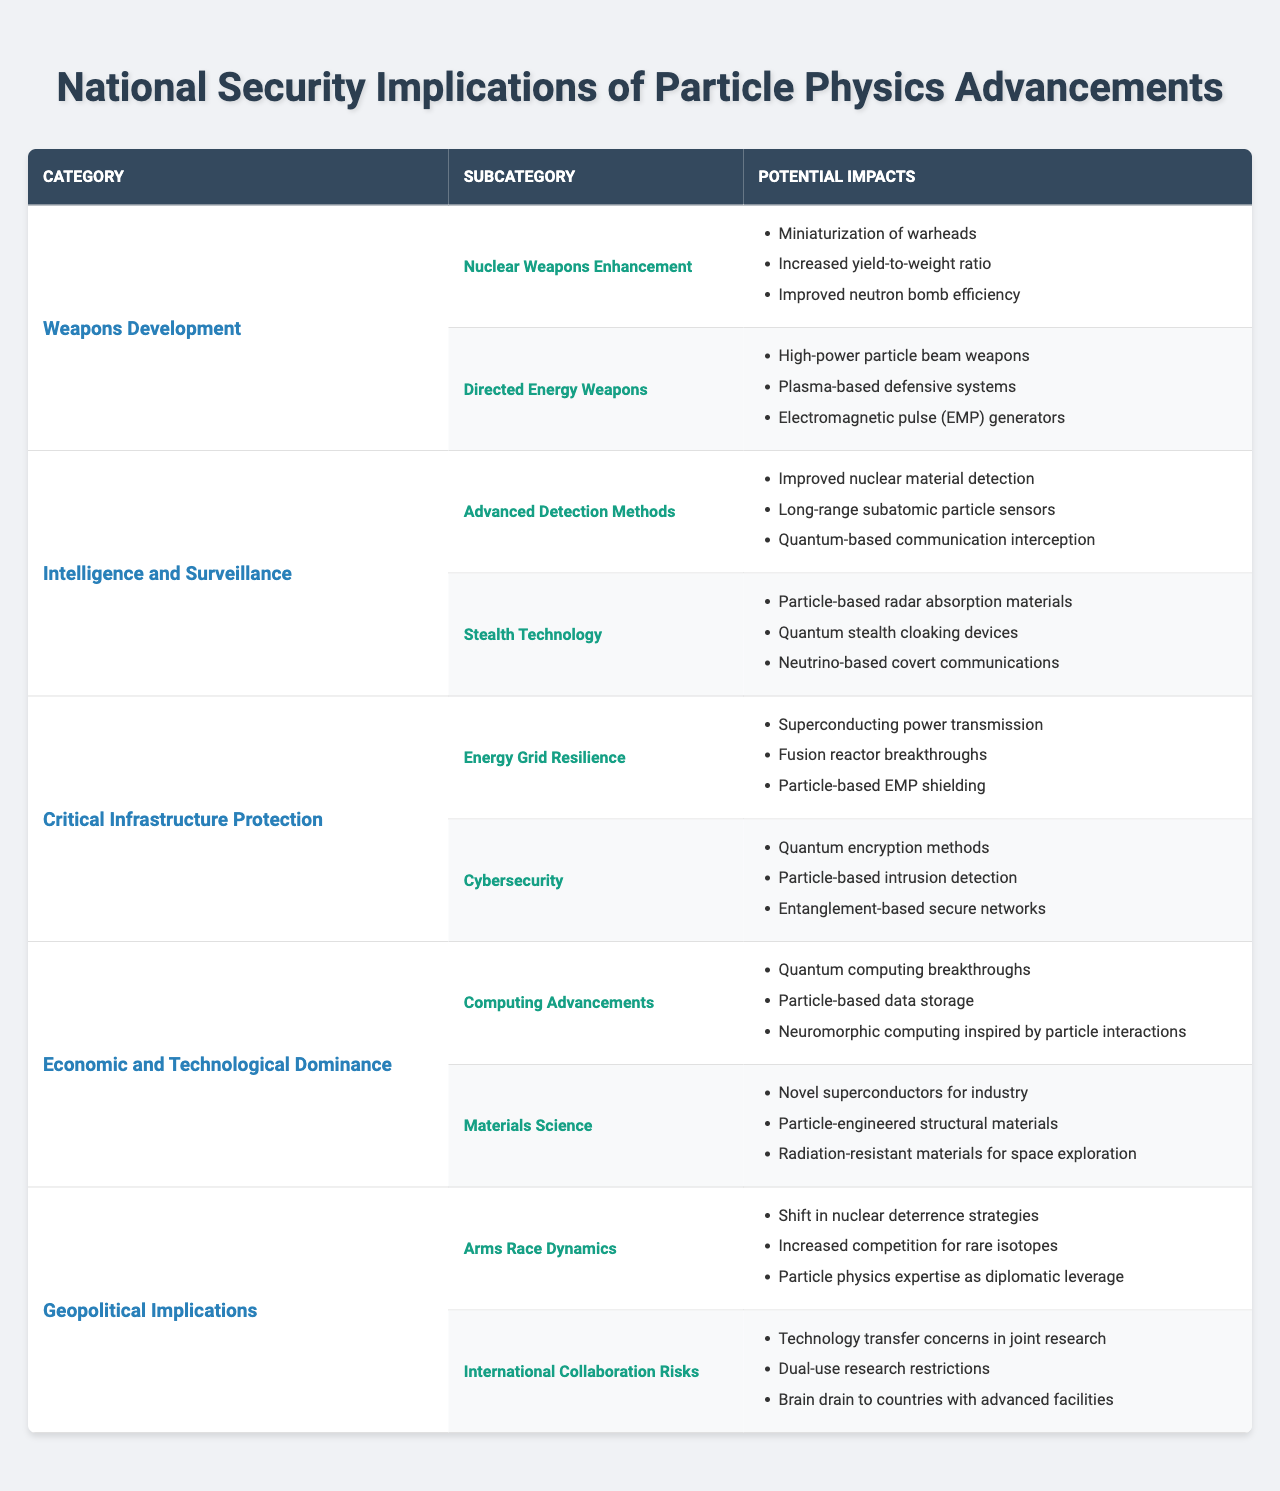What are the potential impacts listed under "Nuclear Weapons Enhancement"? According to the table, the potential impacts listed under "Nuclear Weapons Enhancement" are miniaturization of warheads, increased yield-to-weight ratio, and improved neutron bomb efficiency.
Answer: Miniaturization of warheads, increased yield-to-weight ratio, improved neutron bomb efficiency How many subcategories are under the "Intelligence and Surveillance" category? The table shows that there are two subcategories listed under "Intelligence and Surveillance": Advanced Detection Methods and Stealth Technology. Therefore, the number of subcategories is 2.
Answer: 2 Which potential impact is associated with "Quantum Computing Advancements"? The table indicates that the potential impacts associated with "Quantum Computing Advancements" are quantum computing breakthroughs, particle-based data storage, and neuromorphic computing inspired by particle interactions.
Answer: Quantum computing breakthroughs, particle-based data storage, neuromorphic computing inspired by particle interactions Are directed energy weapons listed as a subcategory under any category? Yes, based on the table, directed energy weapons is listed as a subcategory under "Weapons Development."
Answer: Yes What is the total number of potential impacts listed across all subcategories in the "Critical Infrastructure Protection" category? The "Critical Infrastructure Protection" category has two subcategories: Energy Grid Resilience (with three potential impacts) and Cybersecurity (with three potential impacts). Thus, the total number of potential impacts is 3 + 3 = 6.
Answer: 6 Can you identify two potential impacts from "Stealth Technology"? The table lists three potential impacts under "Stealth Technology": particle-based radar absorption materials, quantum stealth cloaking devices, and neutrino-based covert communications. Two of these are particle-based radar absorption materials and quantum stealth cloaking devices.
Answer: Particle-based radar absorption materials, quantum stealth cloaking devices Which category has the least number of potential impacts, and how many are there? The "Critical Infrastructure Protection" category has two subcategories, each with three potential impacts, while the "Weapons Development" category has two subcategories where one has three potential impacts and the other has three. Therefore, none of the categories have a lesser number as they all have at least three potential impacts.
Answer: None, all have a minimum of three impacts If advancements in materials science lead to radiation-resistant materials, which category and subcategory would this impact belong to? The advancement concerning radiation-resistant materials is listed under the "Materials Science" subcategory, which falls under the "Economic and Technological Dominance" category.
Answer: Economic and Technological Dominance, Materials Science In the context of international collaboration risks, what are two potential impacts mentioned? The table specifies the potential impacts under "International Collaboration Risks" as technology transfer concerns in joint research and dual-use research restrictions.
Answer: Technology transfer concerns in joint research, dual-use research restrictions What impact related to the energy grid is mentioned in the table? The potential impacts related to the energy grid mentioned in the table include superconducting power transmission, fusion reactor breakthroughs, and particle-based EMP shielding.
Answer: Superconducting power transmission, fusion reactor breakthroughs, particle-based EMP shielding 